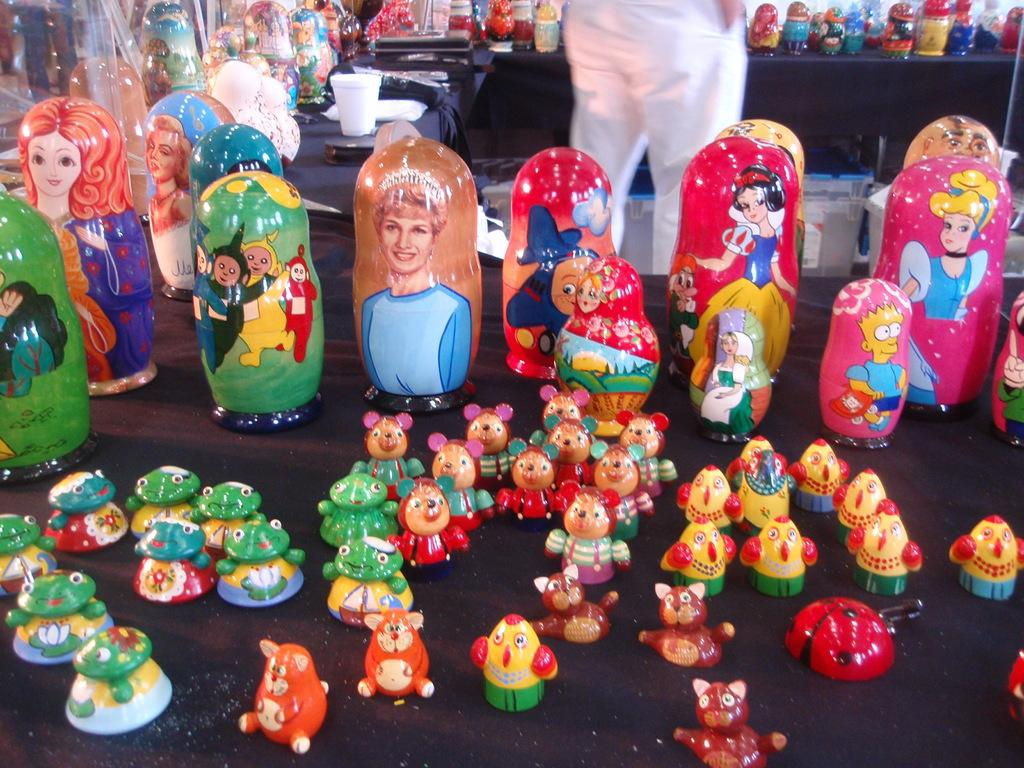What type of objects are present in the image? There are baby toys in the image. Can you describe the person in the image? There is a man at the top side of the image. How many oranges are on the island in the image? There is no island or oranges present in the image. What type of slip is the man wearing in the image? The provided facts do not mention any clothing or slips worn by the man in the image. 